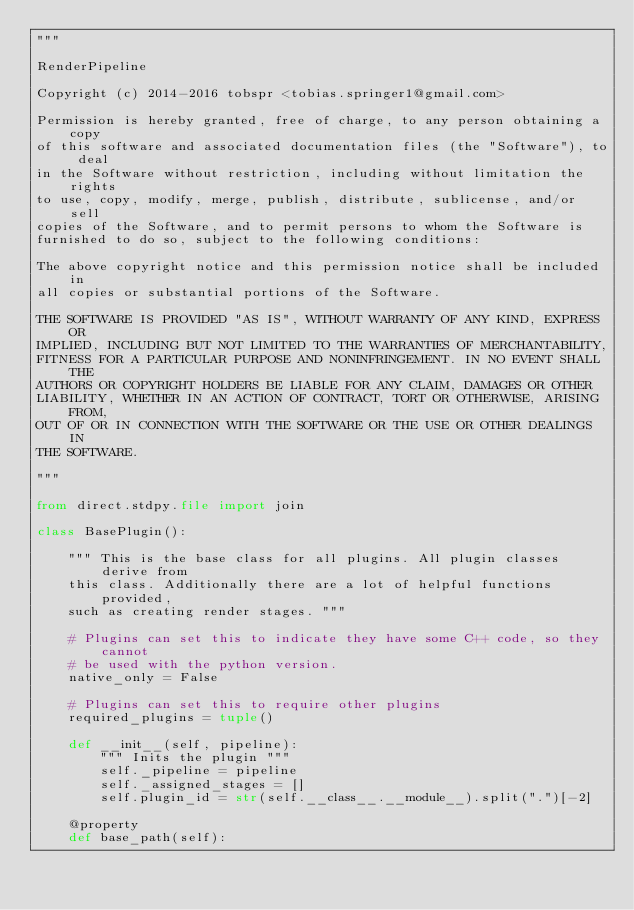Convert code to text. <code><loc_0><loc_0><loc_500><loc_500><_Python_>"""

RenderPipeline

Copyright (c) 2014-2016 tobspr <tobias.springer1@gmail.com>

Permission is hereby granted, free of charge, to any person obtaining a copy
of this software and associated documentation files (the "Software"), to deal
in the Software without restriction, including without limitation the rights
to use, copy, modify, merge, publish, distribute, sublicense, and/or sell
copies of the Software, and to permit persons to whom the Software is
furnished to do so, subject to the following conditions:

The above copyright notice and this permission notice shall be included in
all copies or substantial portions of the Software.

THE SOFTWARE IS PROVIDED "AS IS", WITHOUT WARRANTY OF ANY KIND, EXPRESS OR
IMPLIED, INCLUDING BUT NOT LIMITED TO THE WARRANTIES OF MERCHANTABILITY,
FITNESS FOR A PARTICULAR PURPOSE AND NONINFRINGEMENT. IN NO EVENT SHALL THE
AUTHORS OR COPYRIGHT HOLDERS BE LIABLE FOR ANY CLAIM, DAMAGES OR OTHER
LIABILITY, WHETHER IN AN ACTION OF CONTRACT, TORT OR OTHERWISE, ARISING FROM,
OUT OF OR IN CONNECTION WITH THE SOFTWARE OR THE USE OR OTHER DEALINGS IN
THE SOFTWARE.

"""

from direct.stdpy.file import join

class BasePlugin():

    """ This is the base class for all plugins. All plugin classes derive from
    this class. Additionally there are a lot of helpful functions provided,
    such as creating render stages. """

    # Plugins can set this to indicate they have some C++ code, so they cannot
    # be used with the python version.
    native_only = False

    # Plugins can set this to require other plugins
    required_plugins = tuple()

    def __init__(self, pipeline):
        """ Inits the plugin """
        self._pipeline = pipeline
        self._assigned_stages = []
        self.plugin_id = str(self.__class__.__module__).split(".")[-2]

    @property
    def base_path(self):</code> 